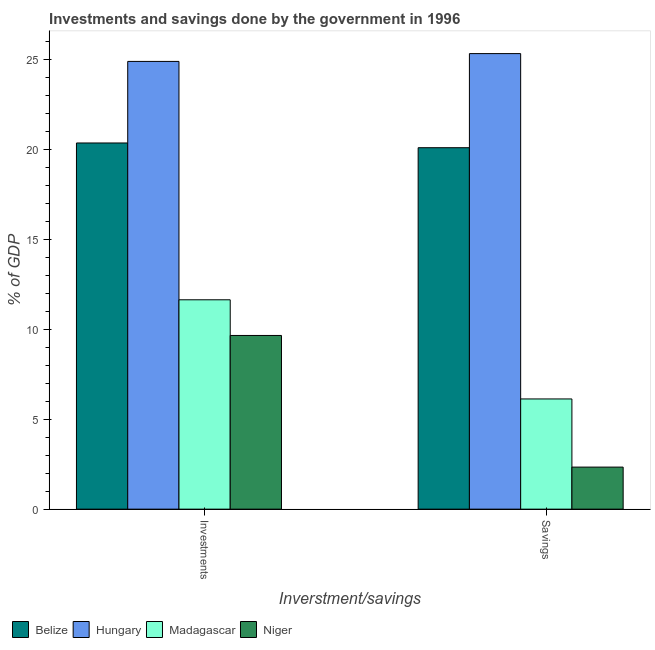How many different coloured bars are there?
Make the answer very short. 4. How many groups of bars are there?
Make the answer very short. 2. Are the number of bars per tick equal to the number of legend labels?
Provide a succinct answer. Yes. Are the number of bars on each tick of the X-axis equal?
Offer a terse response. Yes. How many bars are there on the 1st tick from the left?
Offer a terse response. 4. How many bars are there on the 2nd tick from the right?
Make the answer very short. 4. What is the label of the 1st group of bars from the left?
Your answer should be compact. Investments. What is the investments of government in Niger?
Offer a very short reply. 9.65. Across all countries, what is the maximum savings of government?
Ensure brevity in your answer.  25.32. Across all countries, what is the minimum investments of government?
Offer a very short reply. 9.65. In which country was the savings of government maximum?
Your answer should be very brief. Hungary. In which country was the savings of government minimum?
Make the answer very short. Niger. What is the total savings of government in the graph?
Offer a very short reply. 53.87. What is the difference between the savings of government in Hungary and that in Niger?
Offer a terse response. 22.98. What is the difference between the investments of government in Madagascar and the savings of government in Hungary?
Your response must be concise. -13.68. What is the average savings of government per country?
Your answer should be very brief. 13.47. What is the difference between the savings of government and investments of government in Niger?
Give a very brief answer. -7.32. In how many countries, is the savings of government greater than 6 %?
Give a very brief answer. 3. What is the ratio of the investments of government in Belize to that in Hungary?
Give a very brief answer. 0.82. In how many countries, is the savings of government greater than the average savings of government taken over all countries?
Provide a succinct answer. 2. What does the 3rd bar from the left in Investments represents?
Offer a terse response. Madagascar. What does the 4th bar from the right in Savings represents?
Ensure brevity in your answer.  Belize. What is the difference between two consecutive major ticks on the Y-axis?
Your answer should be very brief. 5. Are the values on the major ticks of Y-axis written in scientific E-notation?
Your response must be concise. No. How are the legend labels stacked?
Give a very brief answer. Horizontal. What is the title of the graph?
Ensure brevity in your answer.  Investments and savings done by the government in 1996. What is the label or title of the X-axis?
Provide a succinct answer. Inverstment/savings. What is the label or title of the Y-axis?
Ensure brevity in your answer.  % of GDP. What is the % of GDP in Belize in Investments?
Offer a very short reply. 20.35. What is the % of GDP in Hungary in Investments?
Give a very brief answer. 24.89. What is the % of GDP in Madagascar in Investments?
Give a very brief answer. 11.64. What is the % of GDP in Niger in Investments?
Make the answer very short. 9.65. What is the % of GDP in Belize in Savings?
Your answer should be very brief. 20.09. What is the % of GDP of Hungary in Savings?
Keep it short and to the point. 25.32. What is the % of GDP in Madagascar in Savings?
Offer a terse response. 6.13. What is the % of GDP in Niger in Savings?
Offer a terse response. 2.34. Across all Inverstment/savings, what is the maximum % of GDP of Belize?
Offer a very short reply. 20.35. Across all Inverstment/savings, what is the maximum % of GDP of Hungary?
Ensure brevity in your answer.  25.32. Across all Inverstment/savings, what is the maximum % of GDP of Madagascar?
Provide a succinct answer. 11.64. Across all Inverstment/savings, what is the maximum % of GDP in Niger?
Your answer should be compact. 9.65. Across all Inverstment/savings, what is the minimum % of GDP in Belize?
Ensure brevity in your answer.  20.09. Across all Inverstment/savings, what is the minimum % of GDP of Hungary?
Provide a succinct answer. 24.89. Across all Inverstment/savings, what is the minimum % of GDP in Madagascar?
Make the answer very short. 6.13. Across all Inverstment/savings, what is the minimum % of GDP of Niger?
Your answer should be very brief. 2.34. What is the total % of GDP in Belize in the graph?
Offer a terse response. 40.44. What is the total % of GDP of Hungary in the graph?
Your answer should be very brief. 50.21. What is the total % of GDP of Madagascar in the graph?
Keep it short and to the point. 17.76. What is the total % of GDP of Niger in the graph?
Give a very brief answer. 11.99. What is the difference between the % of GDP in Belize in Investments and that in Savings?
Provide a short and direct response. 0.26. What is the difference between the % of GDP of Hungary in Investments and that in Savings?
Provide a succinct answer. -0.43. What is the difference between the % of GDP in Madagascar in Investments and that in Savings?
Ensure brevity in your answer.  5.51. What is the difference between the % of GDP of Niger in Investments and that in Savings?
Provide a short and direct response. 7.32. What is the difference between the % of GDP in Belize in Investments and the % of GDP in Hungary in Savings?
Keep it short and to the point. -4.97. What is the difference between the % of GDP in Belize in Investments and the % of GDP in Madagascar in Savings?
Offer a terse response. 14.23. What is the difference between the % of GDP in Belize in Investments and the % of GDP in Niger in Savings?
Your answer should be very brief. 18.01. What is the difference between the % of GDP of Hungary in Investments and the % of GDP of Madagascar in Savings?
Your answer should be very brief. 18.76. What is the difference between the % of GDP of Hungary in Investments and the % of GDP of Niger in Savings?
Give a very brief answer. 22.55. What is the difference between the % of GDP of Madagascar in Investments and the % of GDP of Niger in Savings?
Offer a very short reply. 9.3. What is the average % of GDP in Belize per Inverstment/savings?
Offer a terse response. 20.22. What is the average % of GDP of Hungary per Inverstment/savings?
Give a very brief answer. 25.1. What is the average % of GDP in Madagascar per Inverstment/savings?
Your response must be concise. 8.88. What is the average % of GDP in Niger per Inverstment/savings?
Ensure brevity in your answer.  6. What is the difference between the % of GDP of Belize and % of GDP of Hungary in Investments?
Provide a succinct answer. -4.53. What is the difference between the % of GDP in Belize and % of GDP in Madagascar in Investments?
Your answer should be very brief. 8.72. What is the difference between the % of GDP of Belize and % of GDP of Niger in Investments?
Your answer should be very brief. 10.7. What is the difference between the % of GDP in Hungary and % of GDP in Madagascar in Investments?
Offer a terse response. 13.25. What is the difference between the % of GDP of Hungary and % of GDP of Niger in Investments?
Offer a terse response. 15.23. What is the difference between the % of GDP of Madagascar and % of GDP of Niger in Investments?
Your answer should be very brief. 1.98. What is the difference between the % of GDP in Belize and % of GDP in Hungary in Savings?
Your answer should be very brief. -5.23. What is the difference between the % of GDP of Belize and % of GDP of Madagascar in Savings?
Your response must be concise. 13.96. What is the difference between the % of GDP in Belize and % of GDP in Niger in Savings?
Give a very brief answer. 17.75. What is the difference between the % of GDP of Hungary and % of GDP of Madagascar in Savings?
Offer a terse response. 19.2. What is the difference between the % of GDP of Hungary and % of GDP of Niger in Savings?
Your response must be concise. 22.98. What is the difference between the % of GDP in Madagascar and % of GDP in Niger in Savings?
Offer a very short reply. 3.79. What is the ratio of the % of GDP in Belize in Investments to that in Savings?
Give a very brief answer. 1.01. What is the ratio of the % of GDP in Hungary in Investments to that in Savings?
Provide a short and direct response. 0.98. What is the ratio of the % of GDP of Madagascar in Investments to that in Savings?
Make the answer very short. 1.9. What is the ratio of the % of GDP of Niger in Investments to that in Savings?
Give a very brief answer. 4.13. What is the difference between the highest and the second highest % of GDP in Belize?
Give a very brief answer. 0.26. What is the difference between the highest and the second highest % of GDP in Hungary?
Provide a short and direct response. 0.43. What is the difference between the highest and the second highest % of GDP in Madagascar?
Your answer should be very brief. 5.51. What is the difference between the highest and the second highest % of GDP of Niger?
Provide a short and direct response. 7.32. What is the difference between the highest and the lowest % of GDP in Belize?
Ensure brevity in your answer.  0.26. What is the difference between the highest and the lowest % of GDP of Hungary?
Make the answer very short. 0.43. What is the difference between the highest and the lowest % of GDP of Madagascar?
Your answer should be very brief. 5.51. What is the difference between the highest and the lowest % of GDP of Niger?
Ensure brevity in your answer.  7.32. 